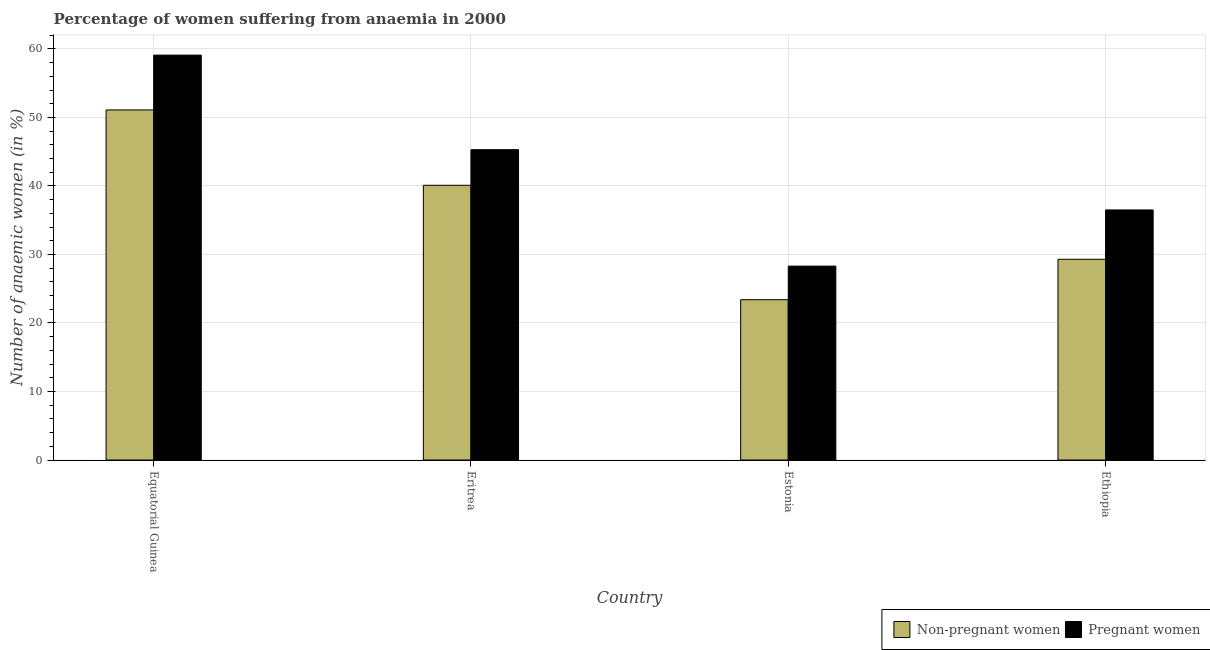How many groups of bars are there?
Give a very brief answer. 4. Are the number of bars on each tick of the X-axis equal?
Your response must be concise. Yes. What is the label of the 3rd group of bars from the left?
Offer a terse response. Estonia. In how many cases, is the number of bars for a given country not equal to the number of legend labels?
Your answer should be very brief. 0. What is the percentage of non-pregnant anaemic women in Equatorial Guinea?
Provide a succinct answer. 51.1. Across all countries, what is the maximum percentage of pregnant anaemic women?
Ensure brevity in your answer.  59.1. Across all countries, what is the minimum percentage of non-pregnant anaemic women?
Make the answer very short. 23.4. In which country was the percentage of pregnant anaemic women maximum?
Offer a very short reply. Equatorial Guinea. In which country was the percentage of pregnant anaemic women minimum?
Ensure brevity in your answer.  Estonia. What is the total percentage of non-pregnant anaemic women in the graph?
Offer a very short reply. 143.9. What is the difference between the percentage of non-pregnant anaemic women in Eritrea and that in Ethiopia?
Make the answer very short. 10.8. What is the average percentage of non-pregnant anaemic women per country?
Your answer should be compact. 35.98. What is the difference between the percentage of non-pregnant anaemic women and percentage of pregnant anaemic women in Ethiopia?
Provide a short and direct response. -7.2. What is the ratio of the percentage of pregnant anaemic women in Estonia to that in Ethiopia?
Your answer should be compact. 0.78. Is the difference between the percentage of pregnant anaemic women in Equatorial Guinea and Eritrea greater than the difference between the percentage of non-pregnant anaemic women in Equatorial Guinea and Eritrea?
Provide a short and direct response. Yes. What is the difference between the highest and the second highest percentage of non-pregnant anaemic women?
Your answer should be compact. 11. What is the difference between the highest and the lowest percentage of non-pregnant anaemic women?
Your answer should be compact. 27.7. What does the 1st bar from the left in Estonia represents?
Keep it short and to the point. Non-pregnant women. What does the 2nd bar from the right in Eritrea represents?
Offer a very short reply. Non-pregnant women. How many bars are there?
Your response must be concise. 8. Are all the bars in the graph horizontal?
Ensure brevity in your answer.  No. Are the values on the major ticks of Y-axis written in scientific E-notation?
Ensure brevity in your answer.  No. Does the graph contain any zero values?
Your answer should be compact. No. How many legend labels are there?
Offer a terse response. 2. What is the title of the graph?
Provide a short and direct response. Percentage of women suffering from anaemia in 2000. What is the label or title of the Y-axis?
Your response must be concise. Number of anaemic women (in %). What is the Number of anaemic women (in %) of Non-pregnant women in Equatorial Guinea?
Make the answer very short. 51.1. What is the Number of anaemic women (in %) in Pregnant women in Equatorial Guinea?
Provide a succinct answer. 59.1. What is the Number of anaemic women (in %) of Non-pregnant women in Eritrea?
Provide a short and direct response. 40.1. What is the Number of anaemic women (in %) in Pregnant women in Eritrea?
Provide a short and direct response. 45.3. What is the Number of anaemic women (in %) in Non-pregnant women in Estonia?
Keep it short and to the point. 23.4. What is the Number of anaemic women (in %) in Pregnant women in Estonia?
Make the answer very short. 28.3. What is the Number of anaemic women (in %) in Non-pregnant women in Ethiopia?
Provide a succinct answer. 29.3. What is the Number of anaemic women (in %) of Pregnant women in Ethiopia?
Keep it short and to the point. 36.5. Across all countries, what is the maximum Number of anaemic women (in %) in Non-pregnant women?
Your answer should be compact. 51.1. Across all countries, what is the maximum Number of anaemic women (in %) of Pregnant women?
Keep it short and to the point. 59.1. Across all countries, what is the minimum Number of anaemic women (in %) of Non-pregnant women?
Make the answer very short. 23.4. Across all countries, what is the minimum Number of anaemic women (in %) of Pregnant women?
Make the answer very short. 28.3. What is the total Number of anaemic women (in %) of Non-pregnant women in the graph?
Your response must be concise. 143.9. What is the total Number of anaemic women (in %) of Pregnant women in the graph?
Your answer should be compact. 169.2. What is the difference between the Number of anaemic women (in %) of Non-pregnant women in Equatorial Guinea and that in Eritrea?
Your answer should be compact. 11. What is the difference between the Number of anaemic women (in %) in Pregnant women in Equatorial Guinea and that in Eritrea?
Provide a short and direct response. 13.8. What is the difference between the Number of anaemic women (in %) of Non-pregnant women in Equatorial Guinea and that in Estonia?
Your answer should be very brief. 27.7. What is the difference between the Number of anaemic women (in %) of Pregnant women in Equatorial Guinea and that in Estonia?
Provide a short and direct response. 30.8. What is the difference between the Number of anaemic women (in %) of Non-pregnant women in Equatorial Guinea and that in Ethiopia?
Your answer should be compact. 21.8. What is the difference between the Number of anaemic women (in %) in Pregnant women in Equatorial Guinea and that in Ethiopia?
Ensure brevity in your answer.  22.6. What is the difference between the Number of anaemic women (in %) of Pregnant women in Eritrea and that in Estonia?
Give a very brief answer. 17. What is the difference between the Number of anaemic women (in %) of Pregnant women in Eritrea and that in Ethiopia?
Give a very brief answer. 8.8. What is the difference between the Number of anaemic women (in %) of Pregnant women in Estonia and that in Ethiopia?
Provide a succinct answer. -8.2. What is the difference between the Number of anaemic women (in %) of Non-pregnant women in Equatorial Guinea and the Number of anaemic women (in %) of Pregnant women in Estonia?
Offer a terse response. 22.8. What is the difference between the Number of anaemic women (in %) in Non-pregnant women in Eritrea and the Number of anaemic women (in %) in Pregnant women in Ethiopia?
Provide a succinct answer. 3.6. What is the average Number of anaemic women (in %) of Non-pregnant women per country?
Give a very brief answer. 35.98. What is the average Number of anaemic women (in %) in Pregnant women per country?
Your answer should be compact. 42.3. What is the difference between the Number of anaemic women (in %) in Non-pregnant women and Number of anaemic women (in %) in Pregnant women in Equatorial Guinea?
Give a very brief answer. -8. What is the ratio of the Number of anaemic women (in %) of Non-pregnant women in Equatorial Guinea to that in Eritrea?
Offer a terse response. 1.27. What is the ratio of the Number of anaemic women (in %) in Pregnant women in Equatorial Guinea to that in Eritrea?
Ensure brevity in your answer.  1.3. What is the ratio of the Number of anaemic women (in %) in Non-pregnant women in Equatorial Guinea to that in Estonia?
Make the answer very short. 2.18. What is the ratio of the Number of anaemic women (in %) in Pregnant women in Equatorial Guinea to that in Estonia?
Keep it short and to the point. 2.09. What is the ratio of the Number of anaemic women (in %) of Non-pregnant women in Equatorial Guinea to that in Ethiopia?
Make the answer very short. 1.74. What is the ratio of the Number of anaemic women (in %) of Pregnant women in Equatorial Guinea to that in Ethiopia?
Provide a succinct answer. 1.62. What is the ratio of the Number of anaemic women (in %) in Non-pregnant women in Eritrea to that in Estonia?
Provide a succinct answer. 1.71. What is the ratio of the Number of anaemic women (in %) in Pregnant women in Eritrea to that in Estonia?
Provide a short and direct response. 1.6. What is the ratio of the Number of anaemic women (in %) of Non-pregnant women in Eritrea to that in Ethiopia?
Make the answer very short. 1.37. What is the ratio of the Number of anaemic women (in %) of Pregnant women in Eritrea to that in Ethiopia?
Give a very brief answer. 1.24. What is the ratio of the Number of anaemic women (in %) in Non-pregnant women in Estonia to that in Ethiopia?
Keep it short and to the point. 0.8. What is the ratio of the Number of anaemic women (in %) in Pregnant women in Estonia to that in Ethiopia?
Give a very brief answer. 0.78. What is the difference between the highest and the second highest Number of anaemic women (in %) of Non-pregnant women?
Your answer should be very brief. 11. What is the difference between the highest and the lowest Number of anaemic women (in %) in Non-pregnant women?
Make the answer very short. 27.7. What is the difference between the highest and the lowest Number of anaemic women (in %) in Pregnant women?
Your answer should be very brief. 30.8. 